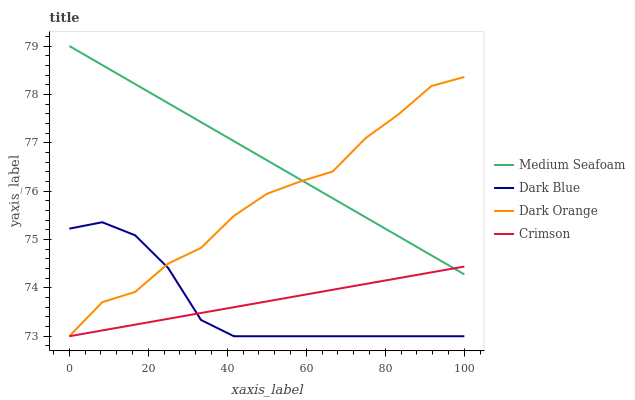Does Dark Blue have the minimum area under the curve?
Answer yes or no. Yes. Does Medium Seafoam have the maximum area under the curve?
Answer yes or no. Yes. Does Medium Seafoam have the minimum area under the curve?
Answer yes or no. No. Does Dark Blue have the maximum area under the curve?
Answer yes or no. No. Is Crimson the smoothest?
Answer yes or no. Yes. Is Dark Orange the roughest?
Answer yes or no. Yes. Is Dark Blue the smoothest?
Answer yes or no. No. Is Dark Blue the roughest?
Answer yes or no. No. Does Crimson have the lowest value?
Answer yes or no. Yes. Does Medium Seafoam have the lowest value?
Answer yes or no. No. Does Medium Seafoam have the highest value?
Answer yes or no. Yes. Does Dark Blue have the highest value?
Answer yes or no. No. Is Dark Blue less than Medium Seafoam?
Answer yes or no. Yes. Is Dark Orange greater than Crimson?
Answer yes or no. Yes. Does Medium Seafoam intersect Dark Orange?
Answer yes or no. Yes. Is Medium Seafoam less than Dark Orange?
Answer yes or no. No. Is Medium Seafoam greater than Dark Orange?
Answer yes or no. No. Does Dark Blue intersect Medium Seafoam?
Answer yes or no. No. 